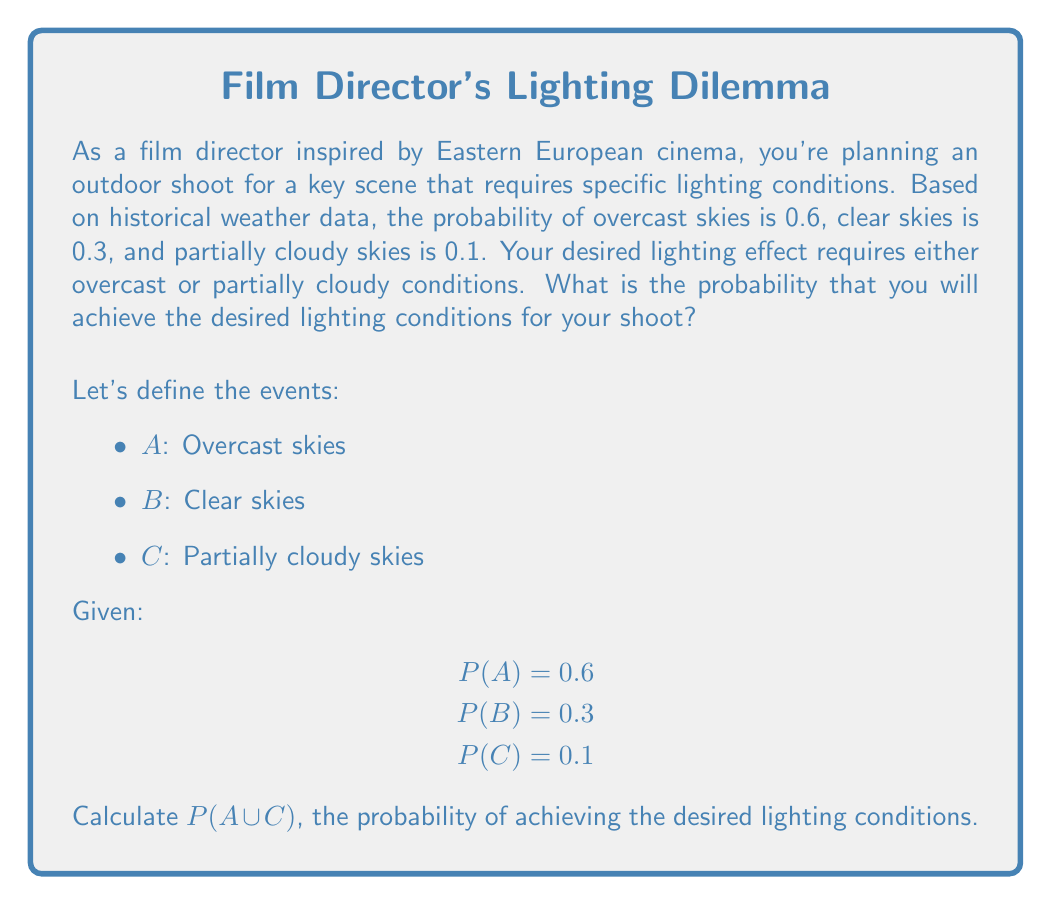Could you help me with this problem? To solve this problem, we need to find the probability of either overcast skies or partially cloudy skies occurring. This is a union of two events, A and C.

Step 1: Identify the formula for the union of two events
The probability of the union of two events is given by:
$$P(A \cup C) = P(A) + P(C) - P(A \cap C)$$

Step 2: Analyze the relationship between events A and C
In this case, the events A (overcast skies) and C (partially cloudy skies) are mutually exclusive, meaning they cannot occur simultaneously. Therefore, $P(A \cap C) = 0$.

Step 3: Substitute the known probabilities into the formula
$$P(A \cup C) = P(A) + P(C) - 0$$
$$P(A \cup C) = 0.6 + 0.1 - 0$$

Step 4: Calculate the final probability
$$P(A \cup C) = 0.7$$

Therefore, the probability of achieving the desired lighting conditions (either overcast or partially cloudy skies) is 0.7 or 70%.
Answer: 0.7 